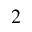<formula> <loc_0><loc_0><loc_500><loc_500>_ { 2 }</formula> 